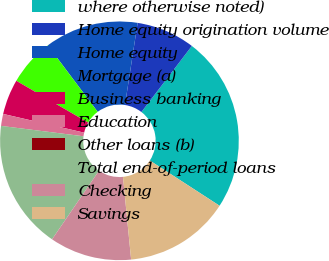Convert chart to OTSL. <chart><loc_0><loc_0><loc_500><loc_500><pie_chart><fcel>where otherwise noted)<fcel>Home equity origination volume<fcel>Home equity<fcel>Mortgage (a)<fcel>Business banking<fcel>Education<fcel>Other loans (b)<fcel>Total end-of-period loans<fcel>Checking<fcel>Savings<nl><fcel>23.78%<fcel>7.94%<fcel>12.69%<fcel>6.36%<fcel>4.77%<fcel>1.6%<fcel>0.02%<fcel>17.45%<fcel>11.11%<fcel>14.28%<nl></chart> 